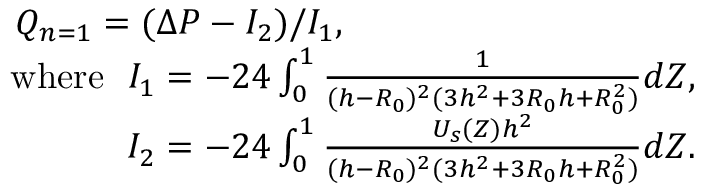Convert formula to latex. <formula><loc_0><loc_0><loc_500><loc_500>\begin{array} { r } { Q _ { n = 1 } = ( \Delta P - I _ { 2 } ) / I _ { 1 } , } \\ { w h e r e I _ { 1 } = - 2 4 \int _ { 0 } ^ { 1 } \frac { 1 } { ( h - R _ { 0 } ) ^ { 2 } ( 3 h ^ { 2 } + 3 R _ { 0 } h + R _ { 0 } ^ { 2 } ) } d Z , } \\ { I _ { 2 } = - 2 4 \int _ { 0 } ^ { 1 } \frac { U _ { s } ( Z ) h ^ { 2 } } { ( h - R _ { 0 } ) ^ { 2 } ( 3 h ^ { 2 } + 3 R _ { 0 } h + R _ { 0 } ^ { 2 } ) } d Z . } \end{array}</formula> 